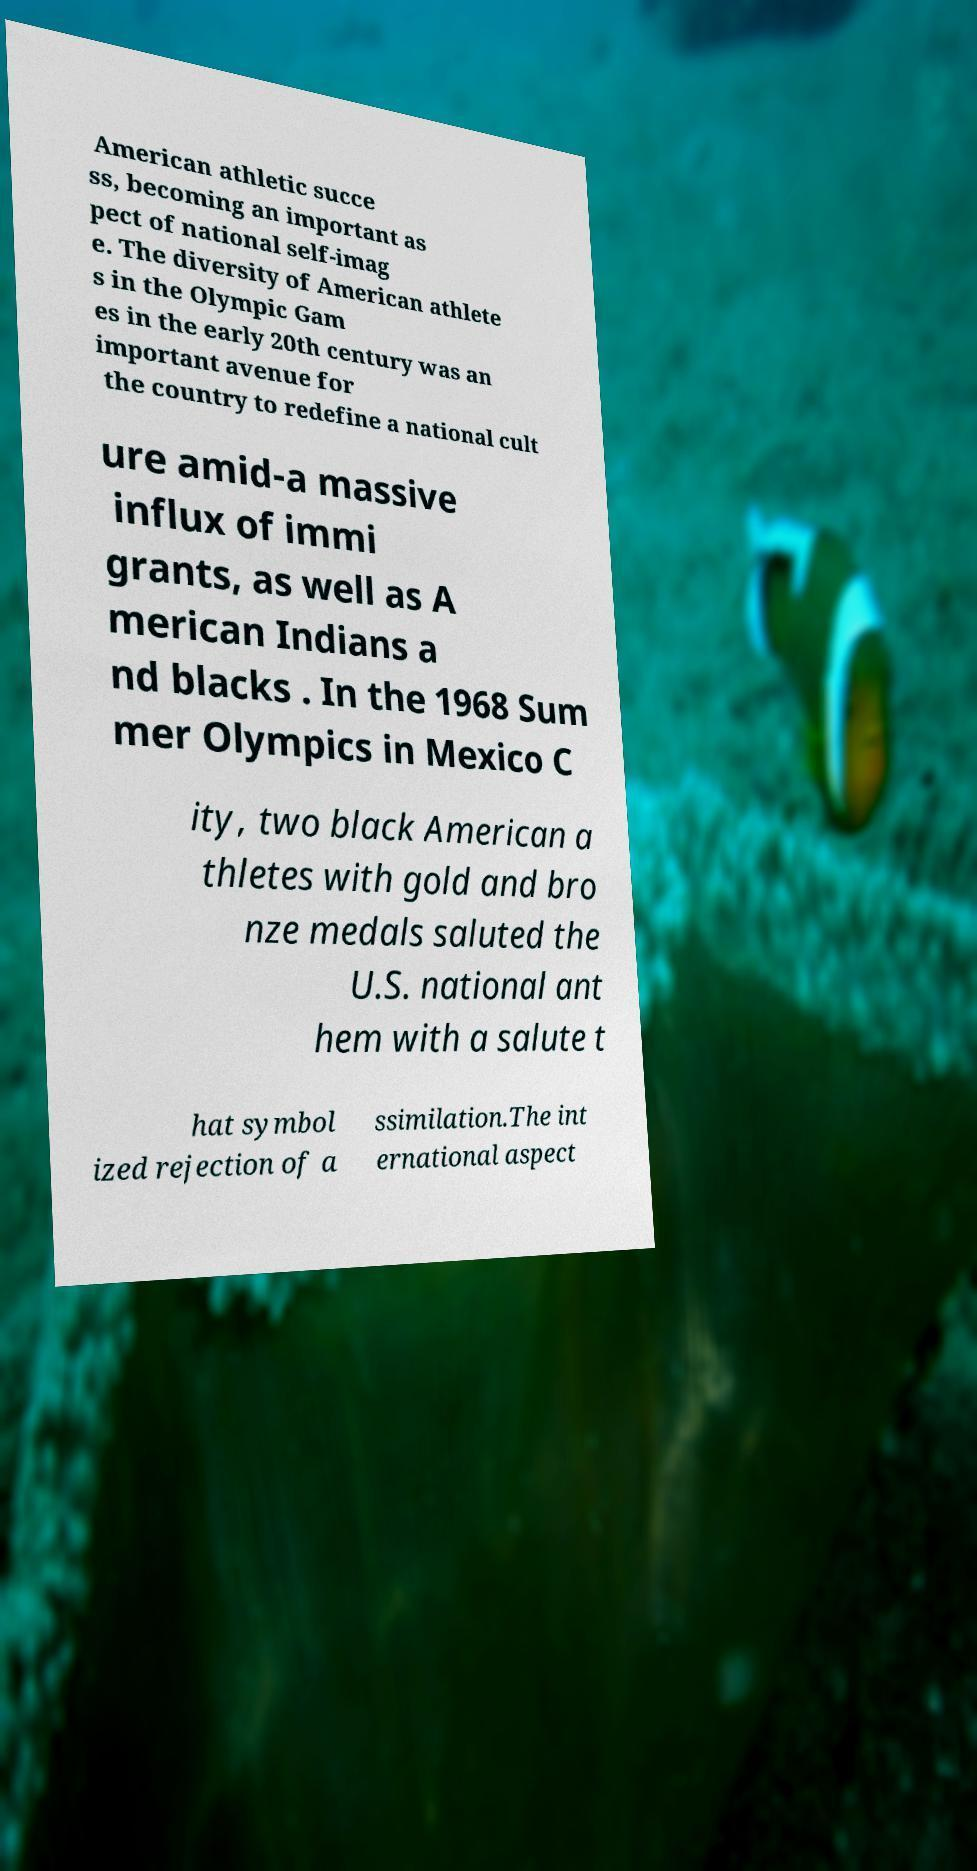Please read and relay the text visible in this image. What does it say? American athletic succe ss, becoming an important as pect of national self-imag e. The diversity of American athlete s in the Olympic Gam es in the early 20th century was an important avenue for the country to redefine a national cult ure amid-a massive influx of immi grants, as well as A merican Indians a nd blacks . In the 1968 Sum mer Olympics in Mexico C ity, two black American a thletes with gold and bro nze medals saluted the U.S. national ant hem with a salute t hat symbol ized rejection of a ssimilation.The int ernational aspect 